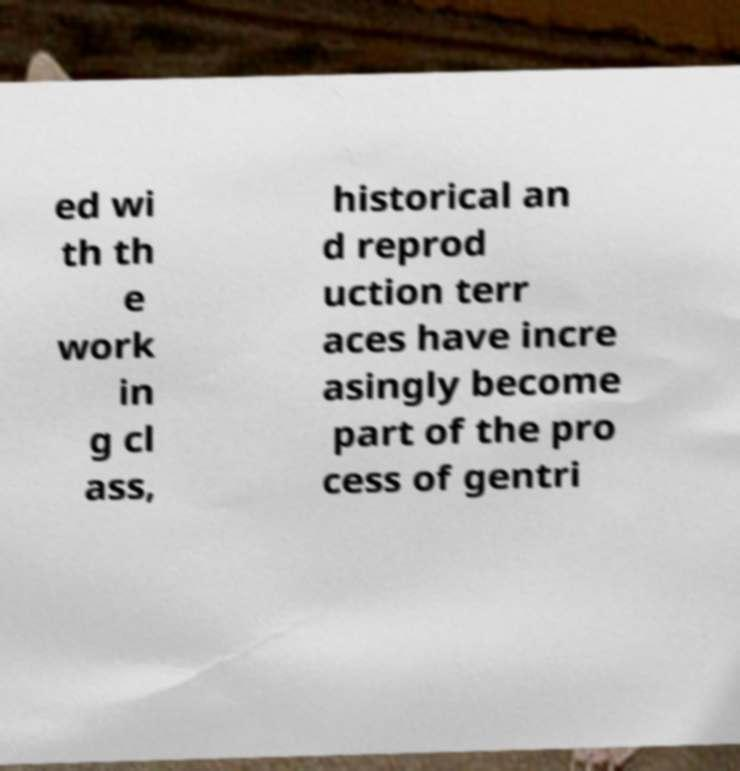What messages or text are displayed in this image? I need them in a readable, typed format. ed wi th th e work in g cl ass, historical an d reprod uction terr aces have incre asingly become part of the pro cess of gentri 